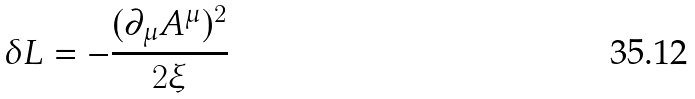<formula> <loc_0><loc_0><loc_500><loc_500>\delta L = - \frac { ( \partial _ { \mu } A ^ { \mu } ) ^ { 2 } } { 2 \xi }</formula> 